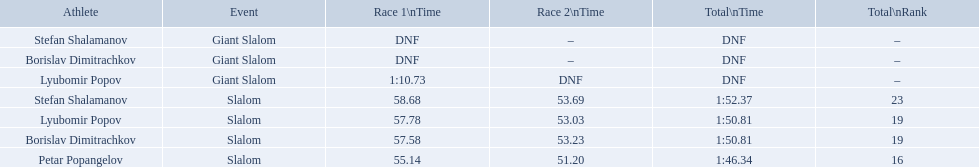What are all the competitions lyubomir popov competed in? Lyubomir Popov, Lyubomir Popov. Of those, which were giant slalom races? Giant Slalom. What was his time in race 1? 1:10.73. Which event is the giant slalom? Giant Slalom, Giant Slalom, Giant Slalom. Which one is lyubomir popov? Lyubomir Popov. What is race 1 tim? 1:10.73. Which occasion is the giant slalom? Giant Slalom, Giant Slalom, Giant Slalom. Which individual is lyubomir popov? Lyubomir Popov. What is the timing of the first race? 1:10.73. What were the competition names involving bulgaria during the 1988 winter olympics? Stefan Shalamanov, Borislav Dimitrachkov, Lyubomir Popov. And which competitors were involved in the giant slalom? Giant Slalom, Giant Slalom, Giant Slalom, Slalom, Slalom, Slalom, Slalom. What were their initial race times? DNF, DNF, 1:10.73. What was lyubomir popov's personal record? 1:10.73. What were the occasion titles for bulgaria at the 1988 winter olympics? Stefan Shalamanov, Borislav Dimitrachkov, Lyubomir Popov. And which athletes took part in the giant slalom? Giant Slalom, Giant Slalom, Giant Slalom, Slalom, Slalom, Slalom, Slalom. What were their first race durations? DNF, DNF, 1:10.73. What was lyubomir popov's individual time? 1:10.73. 